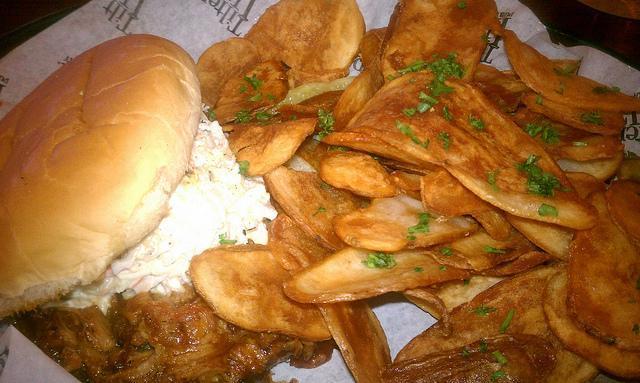How many sandwiches are there?
Give a very brief answer. 1. How many people are pictured?
Give a very brief answer. 0. 